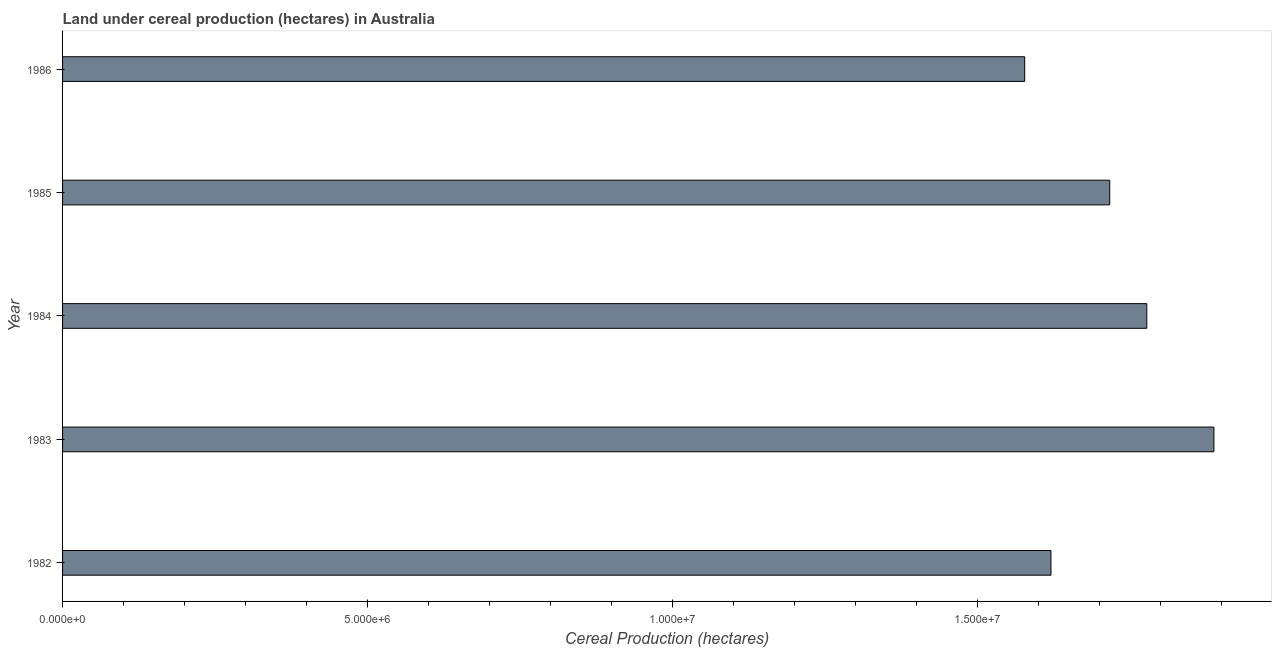What is the title of the graph?
Offer a terse response. Land under cereal production (hectares) in Australia. What is the label or title of the X-axis?
Make the answer very short. Cereal Production (hectares). What is the label or title of the Y-axis?
Your answer should be very brief. Year. What is the land under cereal production in 1982?
Provide a short and direct response. 1.62e+07. Across all years, what is the maximum land under cereal production?
Your response must be concise. 1.89e+07. Across all years, what is the minimum land under cereal production?
Your answer should be very brief. 1.58e+07. In which year was the land under cereal production minimum?
Ensure brevity in your answer.  1986. What is the sum of the land under cereal production?
Your answer should be compact. 8.58e+07. What is the difference between the land under cereal production in 1985 and 1986?
Provide a short and direct response. 1.39e+06. What is the average land under cereal production per year?
Make the answer very short. 1.72e+07. What is the median land under cereal production?
Your answer should be very brief. 1.72e+07. Do a majority of the years between 1986 and 1984 (inclusive) have land under cereal production greater than 8000000 hectares?
Give a very brief answer. Yes. What is the ratio of the land under cereal production in 1985 to that in 1986?
Keep it short and to the point. 1.09. Is the land under cereal production in 1982 less than that in 1983?
Offer a very short reply. Yes. What is the difference between the highest and the second highest land under cereal production?
Make the answer very short. 1.10e+06. What is the difference between the highest and the lowest land under cereal production?
Your answer should be very brief. 3.10e+06. How many bars are there?
Your answer should be compact. 5. What is the difference between two consecutive major ticks on the X-axis?
Give a very brief answer. 5.00e+06. Are the values on the major ticks of X-axis written in scientific E-notation?
Your answer should be very brief. Yes. What is the Cereal Production (hectares) of 1982?
Your answer should be very brief. 1.62e+07. What is the Cereal Production (hectares) in 1983?
Provide a succinct answer. 1.89e+07. What is the Cereal Production (hectares) in 1984?
Your answer should be compact. 1.78e+07. What is the Cereal Production (hectares) in 1985?
Provide a succinct answer. 1.72e+07. What is the Cereal Production (hectares) in 1986?
Your answer should be compact. 1.58e+07. What is the difference between the Cereal Production (hectares) in 1982 and 1983?
Provide a succinct answer. -2.67e+06. What is the difference between the Cereal Production (hectares) in 1982 and 1984?
Offer a terse response. -1.57e+06. What is the difference between the Cereal Production (hectares) in 1982 and 1985?
Your answer should be compact. -9.64e+05. What is the difference between the Cereal Production (hectares) in 1982 and 1986?
Ensure brevity in your answer.  4.30e+05. What is the difference between the Cereal Production (hectares) in 1983 and 1984?
Make the answer very short. 1.10e+06. What is the difference between the Cereal Production (hectares) in 1983 and 1985?
Your answer should be very brief. 1.71e+06. What is the difference between the Cereal Production (hectares) in 1983 and 1986?
Offer a terse response. 3.10e+06. What is the difference between the Cereal Production (hectares) in 1984 and 1985?
Your response must be concise. 6.07e+05. What is the difference between the Cereal Production (hectares) in 1984 and 1986?
Your response must be concise. 2.00e+06. What is the difference between the Cereal Production (hectares) in 1985 and 1986?
Keep it short and to the point. 1.39e+06. What is the ratio of the Cereal Production (hectares) in 1982 to that in 1983?
Offer a terse response. 0.86. What is the ratio of the Cereal Production (hectares) in 1982 to that in 1984?
Your answer should be compact. 0.91. What is the ratio of the Cereal Production (hectares) in 1982 to that in 1985?
Ensure brevity in your answer.  0.94. What is the ratio of the Cereal Production (hectares) in 1982 to that in 1986?
Make the answer very short. 1.03. What is the ratio of the Cereal Production (hectares) in 1983 to that in 1984?
Your answer should be very brief. 1.06. What is the ratio of the Cereal Production (hectares) in 1983 to that in 1985?
Your answer should be compact. 1.1. What is the ratio of the Cereal Production (hectares) in 1983 to that in 1986?
Offer a terse response. 1.2. What is the ratio of the Cereal Production (hectares) in 1984 to that in 1985?
Provide a short and direct response. 1.03. What is the ratio of the Cereal Production (hectares) in 1984 to that in 1986?
Give a very brief answer. 1.13. What is the ratio of the Cereal Production (hectares) in 1985 to that in 1986?
Make the answer very short. 1.09. 